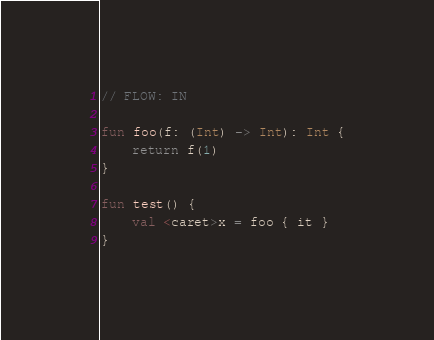Convert code to text. <code><loc_0><loc_0><loc_500><loc_500><_Kotlin_>// FLOW: IN

fun foo(f: (Int) -> Int): Int {
    return f(1)
}

fun test() {
    val <caret>x = foo { it }
}</code> 